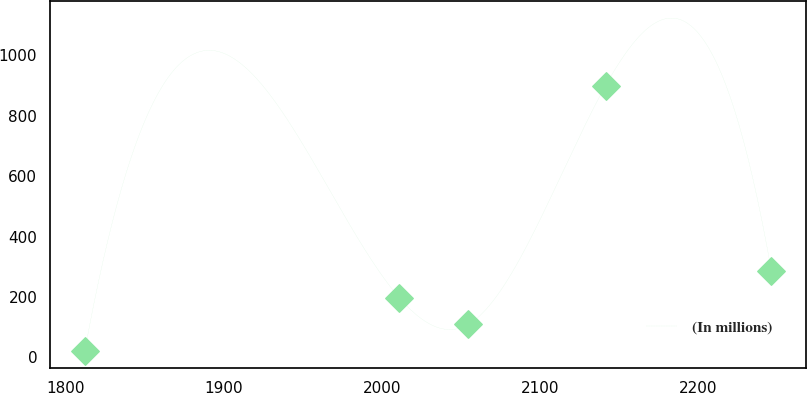<chart> <loc_0><loc_0><loc_500><loc_500><line_chart><ecel><fcel>(In millions)<nl><fcel>1812.04<fcel>20.84<nl><fcel>2011.03<fcel>196.56<nl><fcel>2054.45<fcel>108.7<nl><fcel>2141.31<fcel>899.48<nl><fcel>2246.23<fcel>284.42<nl></chart> 